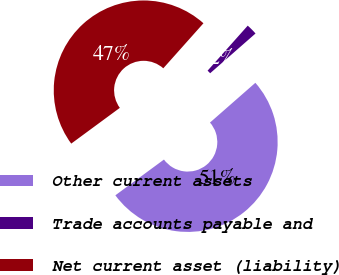Convert chart to OTSL. <chart><loc_0><loc_0><loc_500><loc_500><pie_chart><fcel>Other current assets<fcel>Trade accounts payable and<fcel>Net current asset (liability)<nl><fcel>51.35%<fcel>1.96%<fcel>46.68%<nl></chart> 